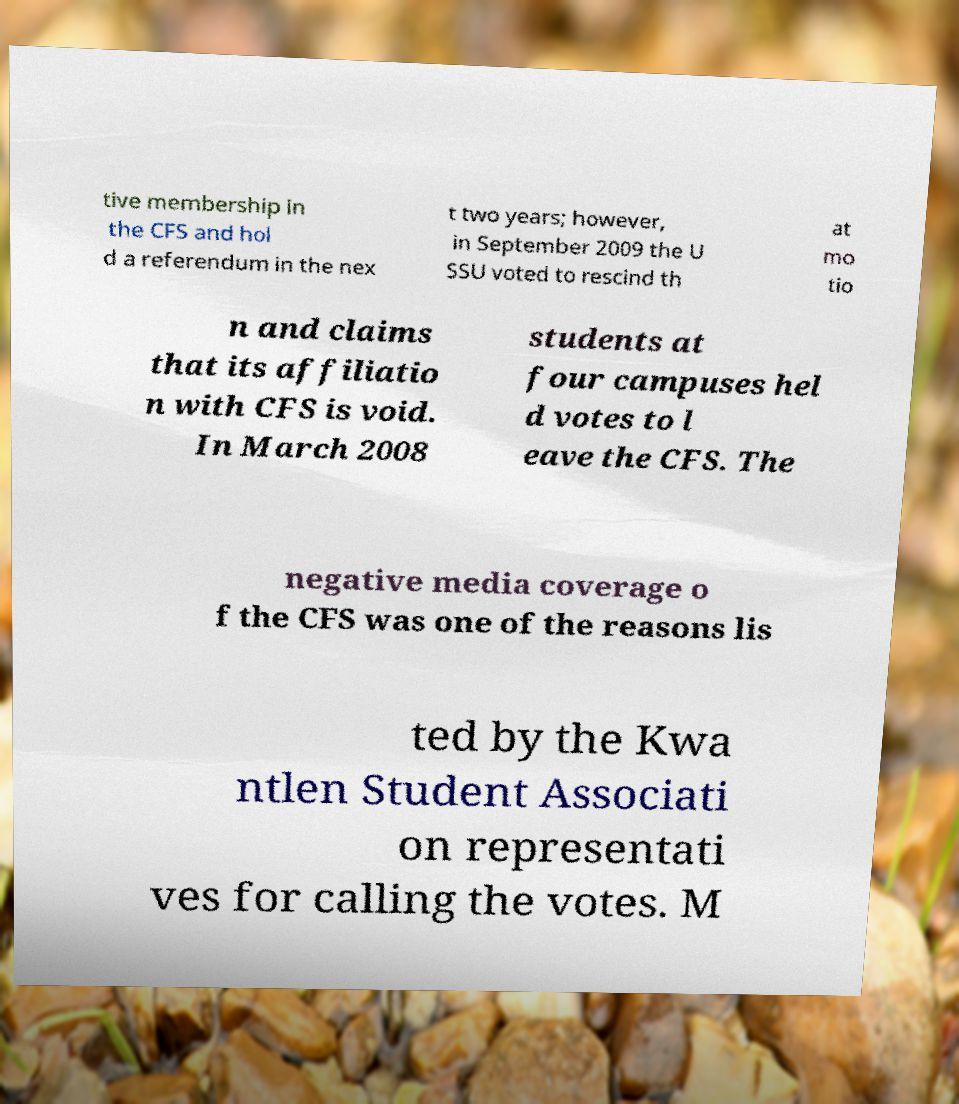There's text embedded in this image that I need extracted. Can you transcribe it verbatim? tive membership in the CFS and hol d a referendum in the nex t two years; however, in September 2009 the U SSU voted to rescind th at mo tio n and claims that its affiliatio n with CFS is void. In March 2008 students at four campuses hel d votes to l eave the CFS. The negative media coverage o f the CFS was one of the reasons lis ted by the Kwa ntlen Student Associati on representati ves for calling the votes. M 